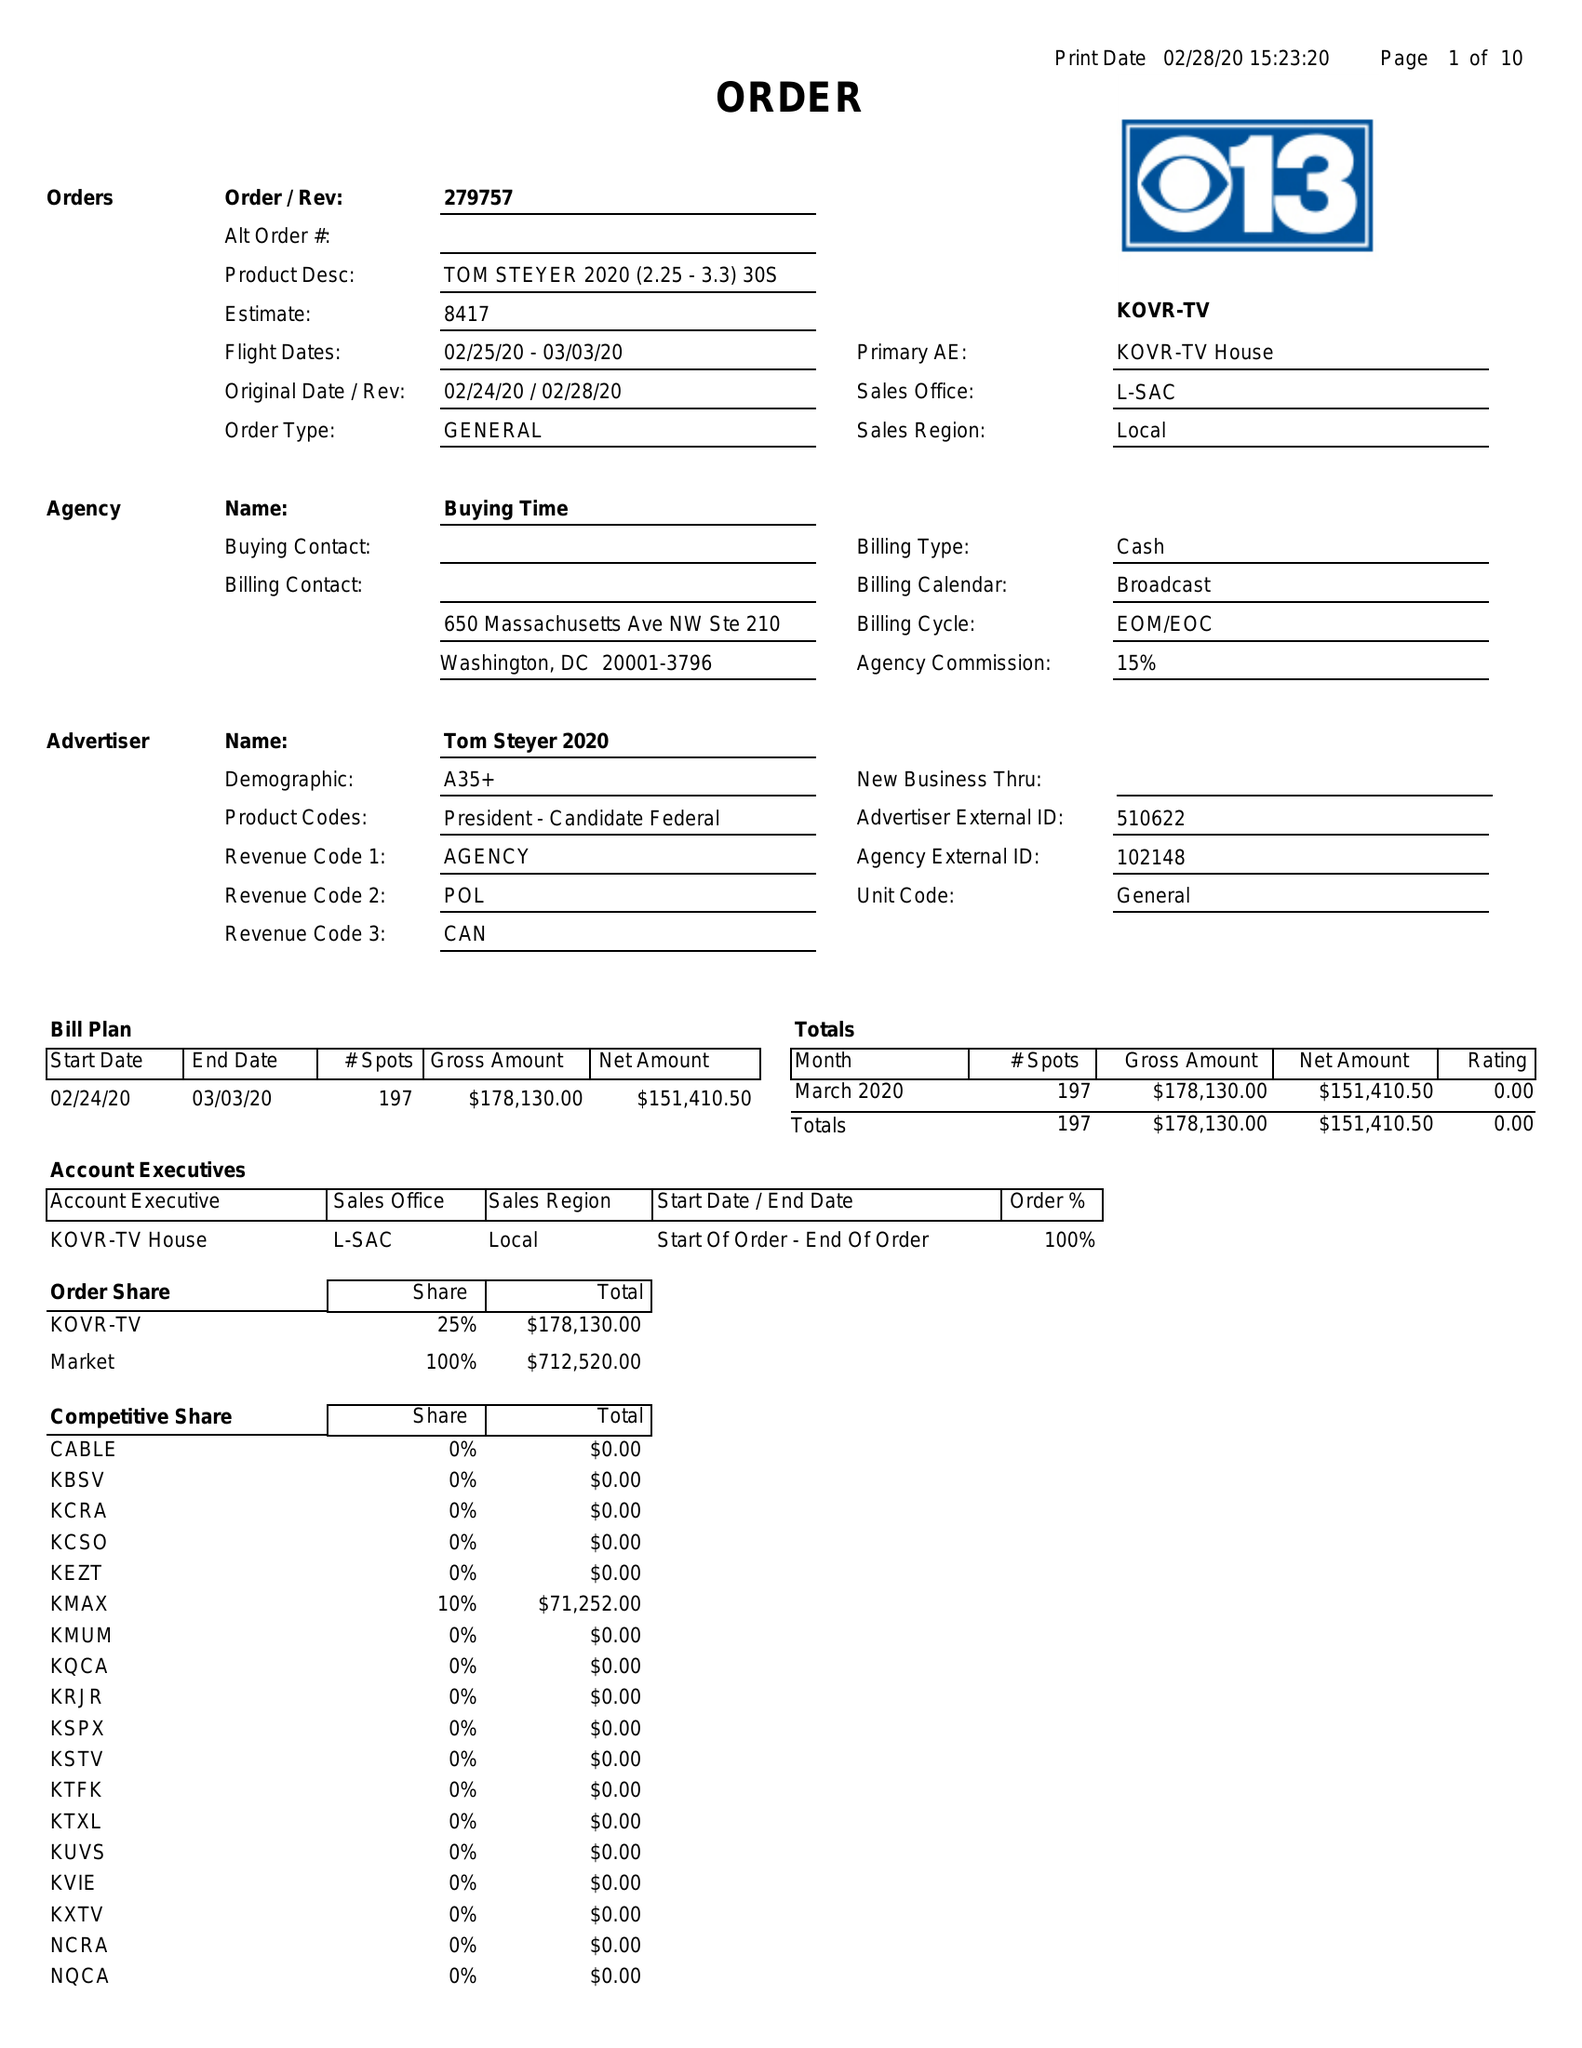What is the value for the contract_num?
Answer the question using a single word or phrase. 279757 